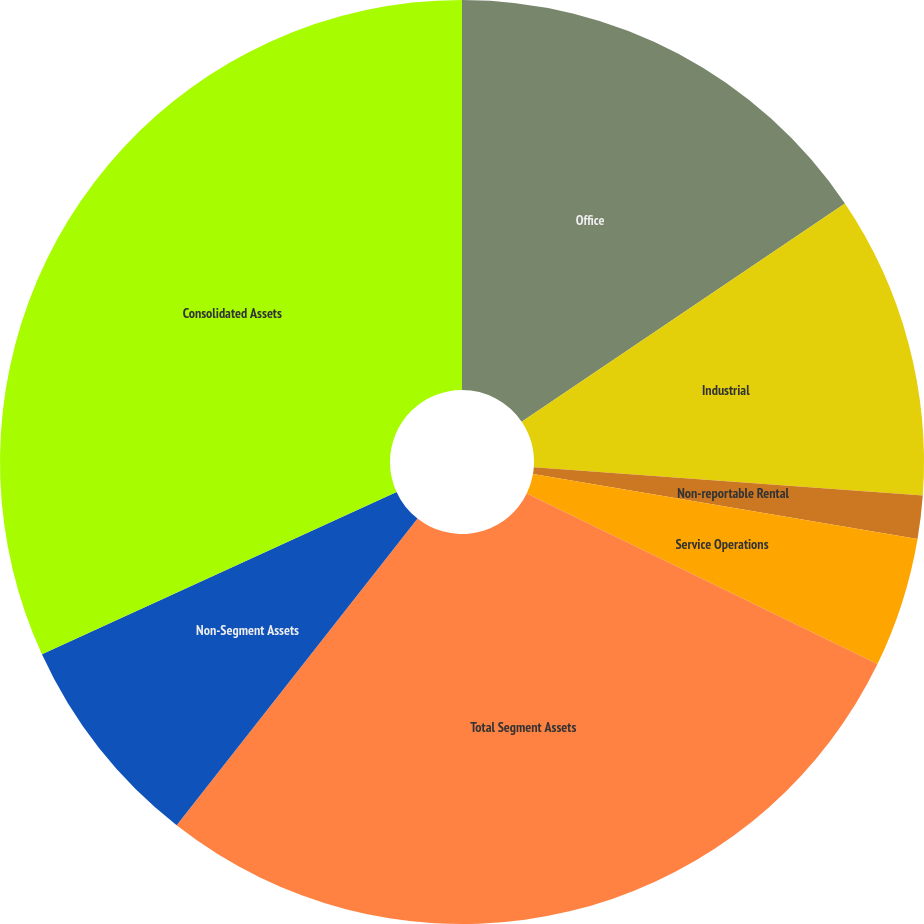Convert chart. <chart><loc_0><loc_0><loc_500><loc_500><pie_chart><fcel>Office<fcel>Industrial<fcel>Non-reportable Rental<fcel>Service Operations<fcel>Total Segment Assets<fcel>Non-Segment Assets<fcel>Consolidated Assets<nl><fcel>15.55%<fcel>10.6%<fcel>1.51%<fcel>4.54%<fcel>28.39%<fcel>7.57%<fcel>31.83%<nl></chart> 